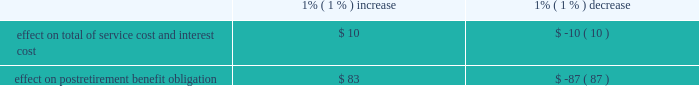United parcel service , inc .
And subsidiaries notes to consolidated financial statements 2014 ( continued ) a discount rate is used to determine the present value of our future benefit obligations .
In 2008 and prior years , the discount rate for u.s .
Plans was determined by matching the expected cash flows to a yield curve based on long-term , high quality fixed income debt instruments available as of the measurement date .
In 2008 , we reduced the population of bonds from which the yield curve was developed to better reflect bonds we would more likely consider to settle our obligations .
In 2009 , we further enhanced this process for plans in the u.s .
By using a bond matching approach to select specific bonds that would satisfy our projected benefit payments .
We believe the bond matching approach more closely reflects the process we would employ to settle our pension and postretirement benefit obligations .
These modifications had an impact of increasing the pension benefits and postretirement medical benefits discount rate on average 31 and 51 basis points for 2009 and 25 and 17 basis points for 2008 .
For 2009 , each basis point increase in the discount rate decreases the projected benefit obligation by approximately $ 25 million and $ 3 million for pension and postretirement medical benefits , respectively .
For our international plans , the discount rate is selected based on high quality fixed income indices available in the country in which the plan is domiciled .
These assumptions are updated annually .
An assumption for expected return on plan assets is used to determine a component of net periodic benefit cost for the fiscal year .
This assumption for our u.s .
Plans was developed using a long-term projection of returns for each asset class , and taking into consideration our target asset allocation .
The expected return for each asset class is a function of passive , long-term capital market assumptions and excess returns generated from active management .
The capital market assumptions used are provided by independent investment advisors , while excess return assumptions are supported by historical performance , fund mandates and investment expectations .
In addition , we compare the expected return on asset assumption with the average historical rate of return these plans have been able to generate .
For the ups retirement plan , we use a market-related valuation method for recognizing investment gains or losses .
Investment gains or losses are the difference between the expected and actual return based on the market- related value of assets .
This method recognizes investment gains or losses over a five year period from the year in which they occur , which reduces year-to-year volatility in pension expense .
Our expense in future periods will be impacted as gains or losses are recognized in the market-related value of assets .
For plans outside the u.s. , consideration is given to local market expectations of long-term returns .
Strategic asset allocations are determined by country , based on the nature of liabilities and considering the demographic composition of the plan participants .
Health care cost trends are used to project future postretirement benefits payable from our plans .
For year-end 2009 u.s .
Plan obligations , future postretirement medical benefit costs were forecasted assuming an initial annual increase of 8.0% ( 8.0 % ) , decreasing to 5.0% ( 5.0 % ) by the year 2016 and with consistent annual increases at those ultimate levels thereafter .
Assumed health care cost trends have a significant effect on the amounts reported for the u.s .
Postretirement medical plans .
A one-percent change in assumed health care cost trend rates would have the following effects ( in millions ) : .

What is the current postretirement benefit obligation? 
Computations: (83 / 1%)
Answer: 8300.0. 